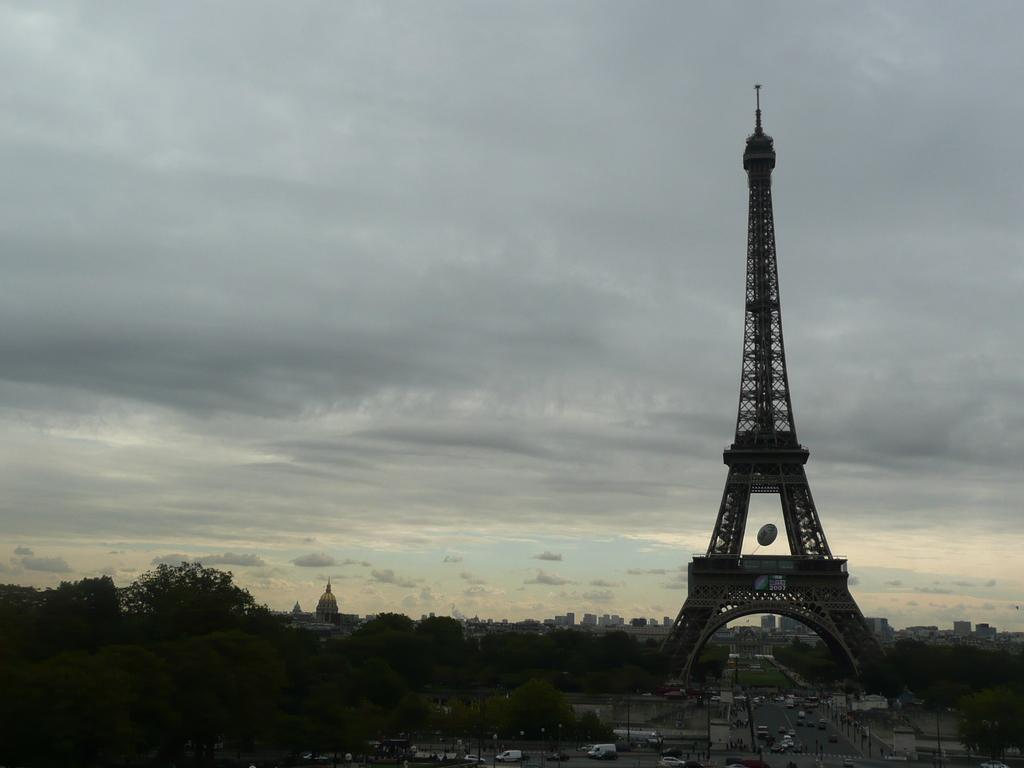Describe this image in one or two sentences. On the right side of the image we can see an eiffel tower. At the bottom we can see vehicles on the road. In the background there are trees, buildings and sky. 